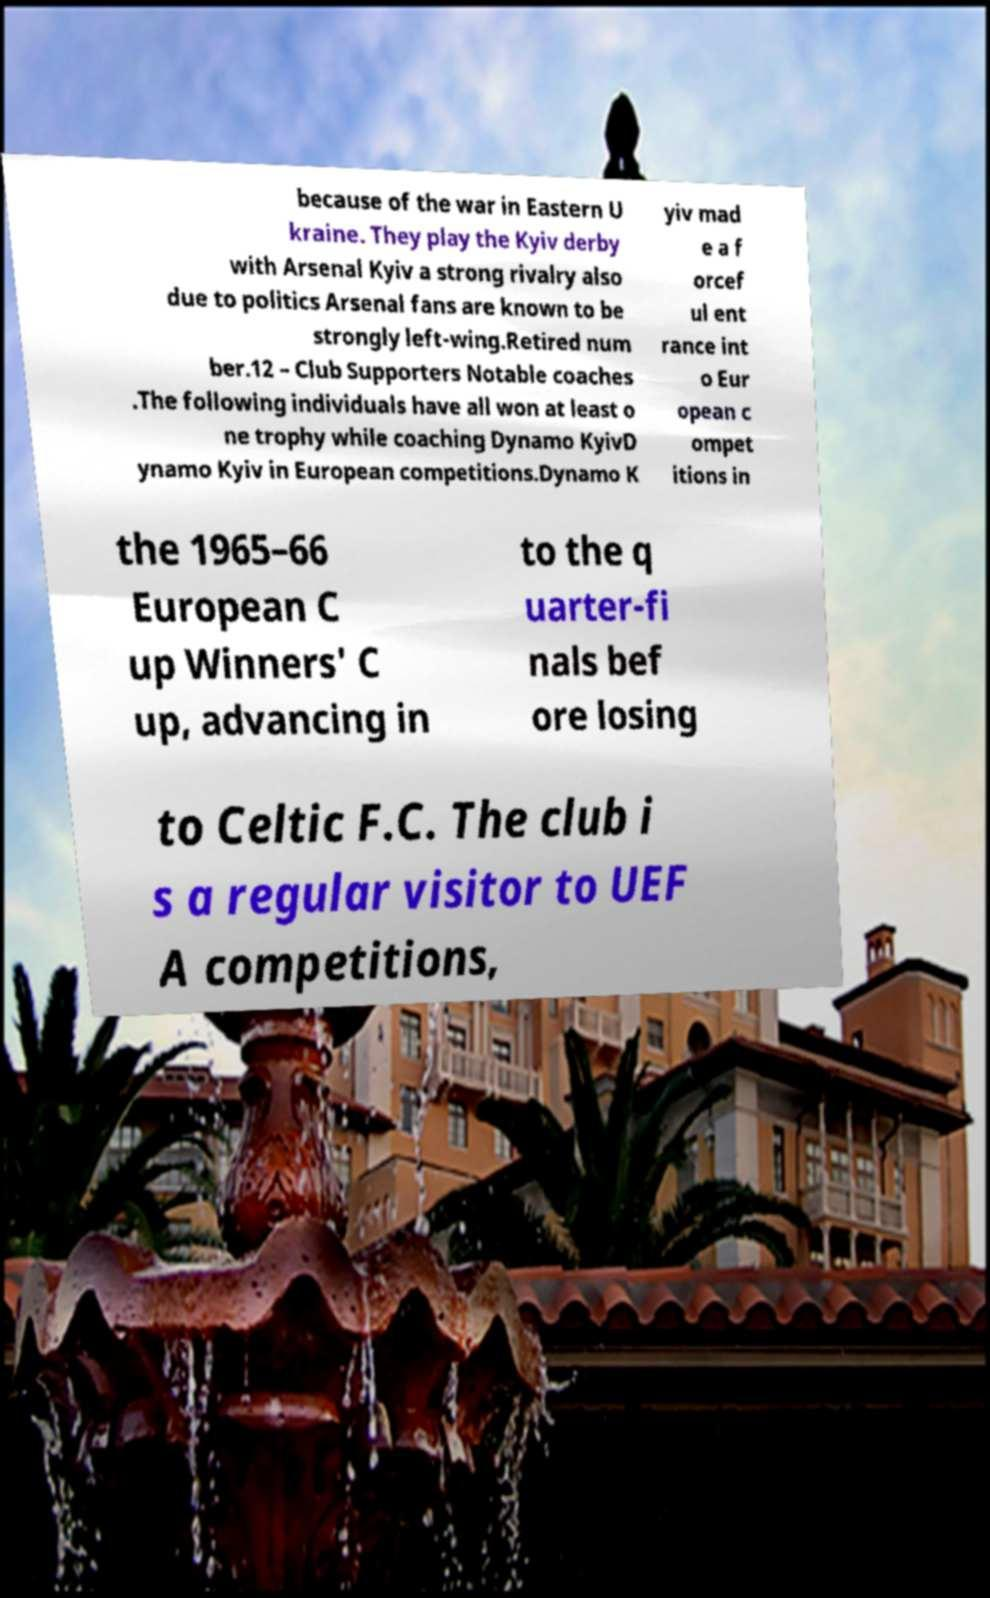Please identify and transcribe the text found in this image. because of the war in Eastern U kraine. They play the Kyiv derby with Arsenal Kyiv a strong rivalry also due to politics Arsenal fans are known to be strongly left-wing.Retired num ber.12 – Club Supporters Notable coaches .The following individuals have all won at least o ne trophy while coaching Dynamo KyivD ynamo Kyiv in European competitions.Dynamo K yiv mad e a f orcef ul ent rance int o Eur opean c ompet itions in the 1965–66 European C up Winners' C up, advancing in to the q uarter-fi nals bef ore losing to Celtic F.C. The club i s a regular visitor to UEF A competitions, 